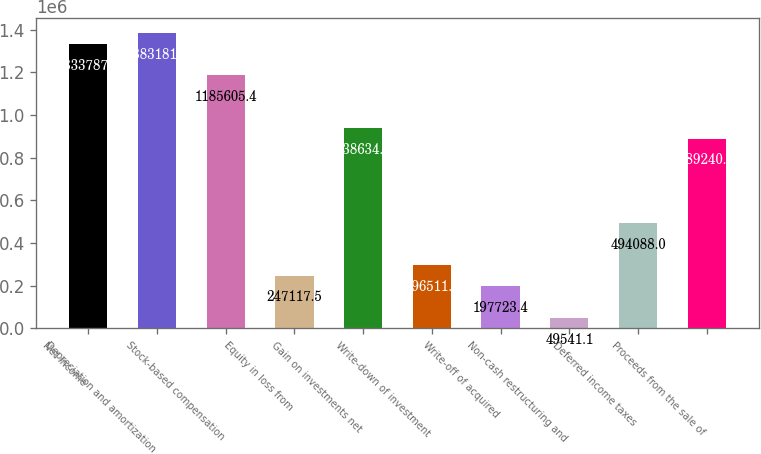<chart> <loc_0><loc_0><loc_500><loc_500><bar_chart><fcel>Net income<fcel>Depreciation and amortization<fcel>Stock-based compensation<fcel>Equity in loss from<fcel>Gain on investments net<fcel>Write-down of investment<fcel>Write-off of acquired<fcel>Non-cash restructuring and<fcel>Deferred income taxes<fcel>Proceeds from the sale of<nl><fcel>1.33379e+06<fcel>1.38318e+06<fcel>1.18561e+06<fcel>247118<fcel>938635<fcel>296512<fcel>197723<fcel>49541.1<fcel>494088<fcel>889241<nl></chart> 